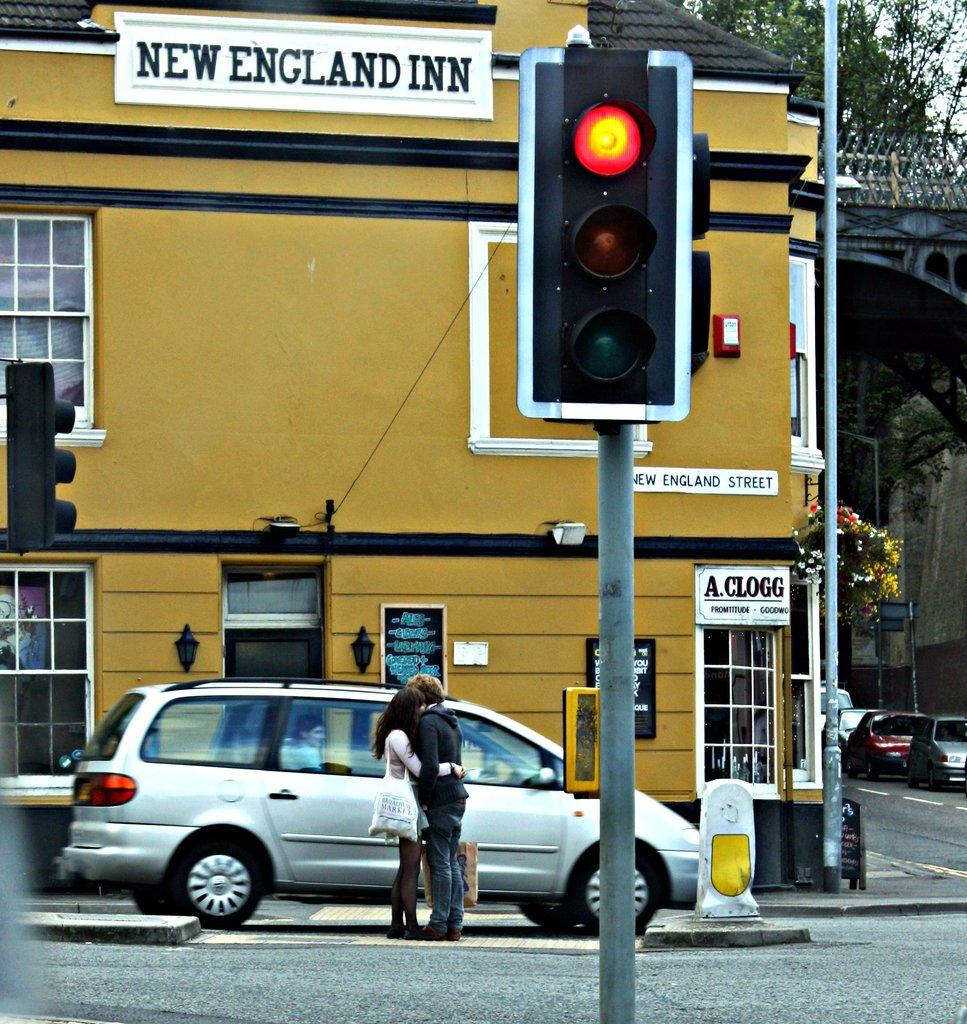<image>
Render a clear and concise summary of the photo. A silver van with two people in front of it is on New England Street. 